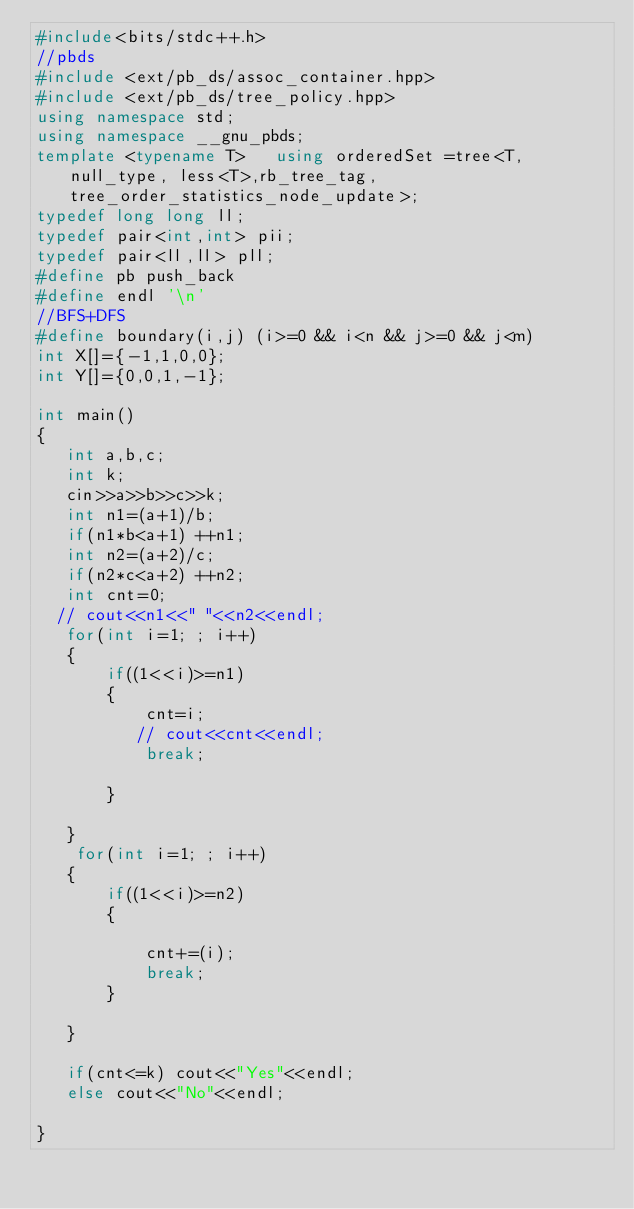<code> <loc_0><loc_0><loc_500><loc_500><_C++_>#include<bits/stdc++.h>
//pbds
#include <ext/pb_ds/assoc_container.hpp>
#include <ext/pb_ds/tree_policy.hpp>
using namespace std;
using namespace __gnu_pbds;
template <typename T>   using orderedSet =tree<T, null_type, less<T>,rb_tree_tag, tree_order_statistics_node_update>;
typedef long long ll;
typedef pair<int,int> pii;
typedef pair<ll,ll> pll;
#define pb push_back
#define endl '\n'
//BFS+DFS
#define boundary(i,j) (i>=0 && i<n && j>=0 && j<m)
int X[]={-1,1,0,0};
int Y[]={0,0,1,-1};

int main()
{
   int a,b,c;
   int k;
   cin>>a>>b>>c>>k;
   int n1=(a+1)/b;
   if(n1*b<a+1) ++n1;
   int n2=(a+2)/c;
   if(n2*c<a+2) ++n2;
   int cnt=0;
  // cout<<n1<<" "<<n2<<endl;
   for(int i=1; ; i++)
   {
       if((1<<i)>=n1)
       {
           cnt=i;
          // cout<<cnt<<endl;
           break;

       }

   }
    for(int i=1; ; i++)
   {
       if((1<<i)>=n2)
       {

           cnt+=(i);
           break;
       }

   }

   if(cnt<=k) cout<<"Yes"<<endl;
   else cout<<"No"<<endl;

}


</code> 